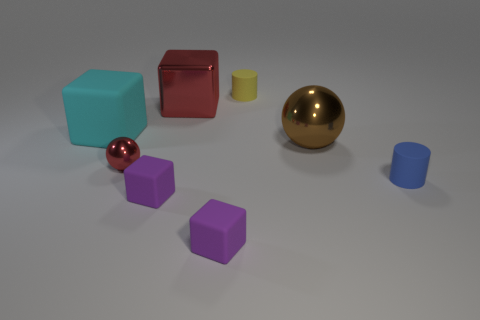Is there another red object that has the same shape as the large red thing?
Give a very brief answer. No. What color is the metal cube that is the same size as the cyan object?
Your answer should be compact. Red. Are there fewer cyan blocks that are on the left side of the tiny blue matte object than balls that are behind the red shiny sphere?
Ensure brevity in your answer.  No. There is a cylinder to the left of the blue cylinder; is its size the same as the blue rubber cylinder?
Your answer should be very brief. Yes. What is the shape of the large object in front of the cyan block?
Make the answer very short. Sphere. Is the number of yellow rubber cylinders greater than the number of tiny purple rubber blocks?
Keep it short and to the point. No. There is a big metal block that is right of the tiny sphere; does it have the same color as the small sphere?
Your answer should be compact. Yes. How many objects are cylinders on the left side of the blue object or purple cubes that are on the right side of the large red thing?
Your answer should be very brief. 2. How many small things are behind the blue cylinder and on the right side of the big red cube?
Give a very brief answer. 1. Is the material of the small red sphere the same as the cyan thing?
Your answer should be very brief. No. 